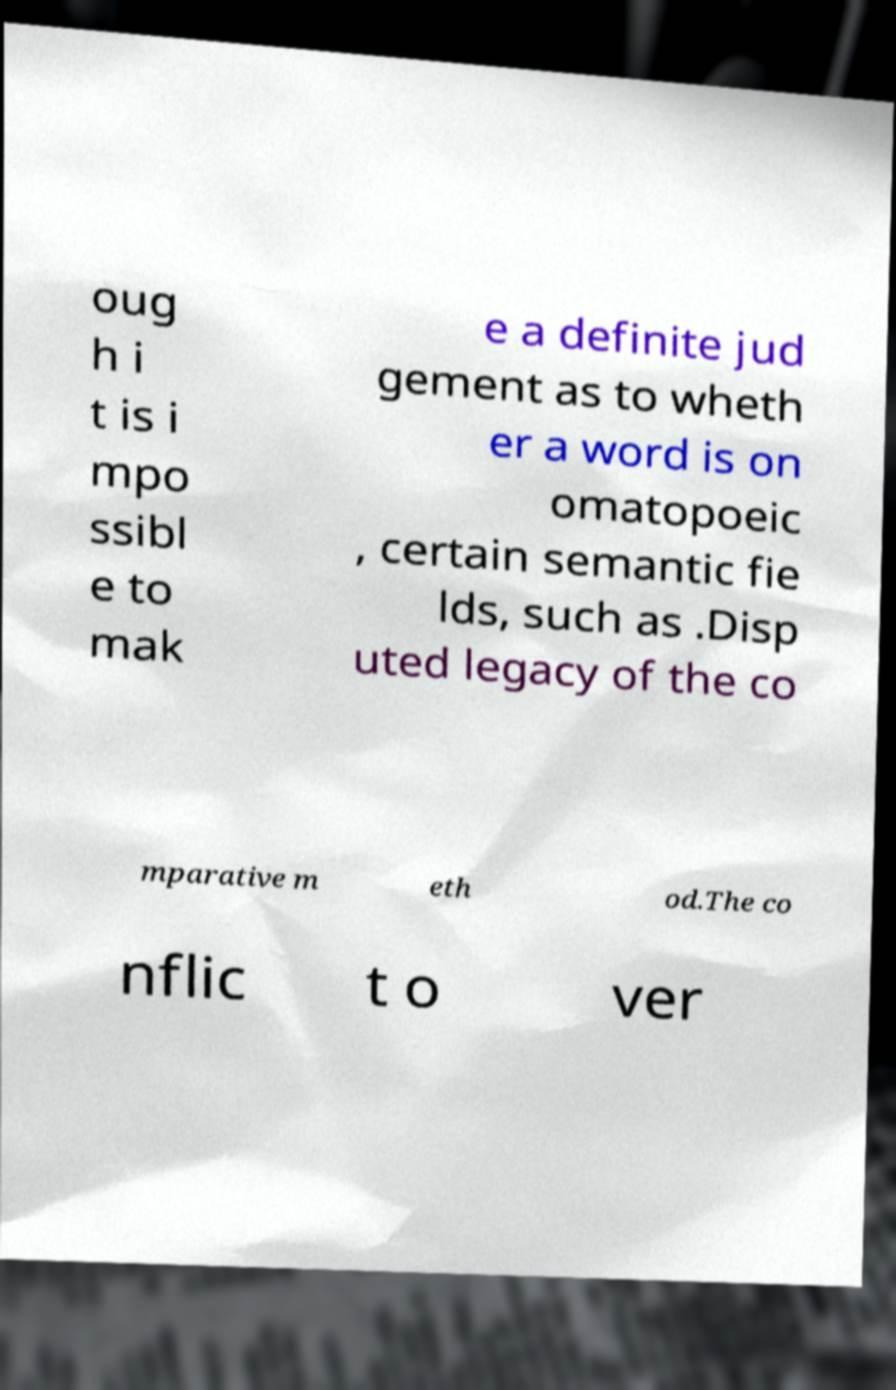Can you accurately transcribe the text from the provided image for me? oug h i t is i mpo ssibl e to mak e a definite jud gement as to wheth er a word is on omatopoeic , certain semantic fie lds, such as .Disp uted legacy of the co mparative m eth od.The co nflic t o ver 